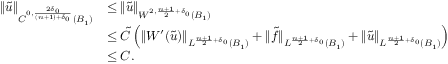Convert formula to latex. <formula><loc_0><loc_0><loc_500><loc_500>\begin{array} { r l } { \| \tilde { u } \| _ { C ^ { 0 , \frac { 2 \delta _ { 0 } } { ( n + 1 ) + \delta _ { 0 } } } ( B _ { 1 } ) } } & { \leq \| \tilde { u } \| _ { W ^ { 2 , \frac { n + 1 } { 2 } + \delta _ { 0 } } ( B _ { 1 } ) } } \\ & { \leq \tilde { C } \left ( \| W ^ { \prime } ( \tilde { u } ) \| _ { L ^ { \frac { n + 1 } { 2 } + \delta _ { 0 } } ( B _ { 1 } ) } + \| \tilde { f } \| _ { L ^ { \frac { n + 1 } { 2 } + \delta _ { 0 } } ( B _ { 1 } ) } + \| \tilde { u } \| _ { L ^ { \frac { n + 1 } { 2 } + \delta _ { 0 } } ( B _ { 1 } ) } \right ) } \\ & { \leq C . } \end{array}</formula> 